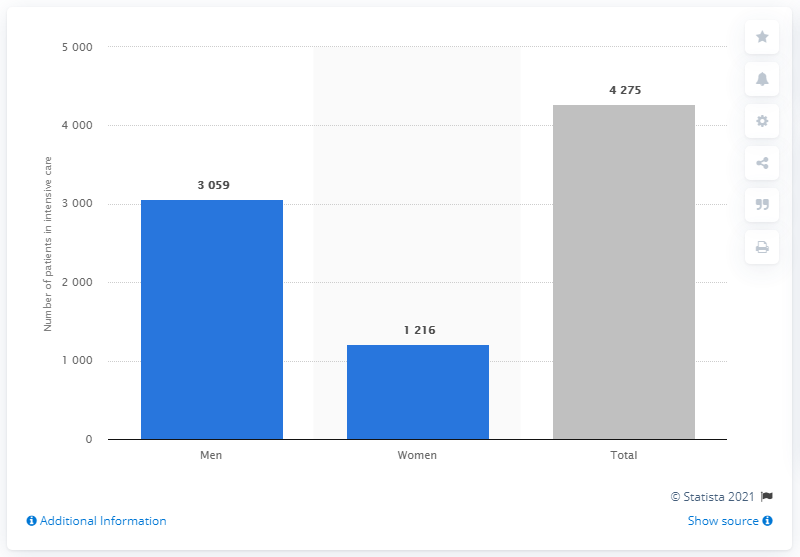Based on the trend in this chart, what could be some potential public health measures to address the issue? Public health measures could include targeted communication and interventions aimed at groups with higher rates of severe cases, increased availability of protective gear for high-risk professions, and further research into the underlying causes of these disparities to inform future actions. 